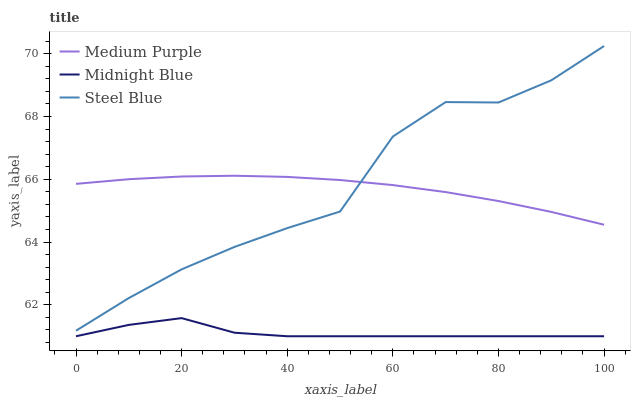Does Midnight Blue have the minimum area under the curve?
Answer yes or no. Yes. Does Steel Blue have the maximum area under the curve?
Answer yes or no. Yes. Does Steel Blue have the minimum area under the curve?
Answer yes or no. No. Does Midnight Blue have the maximum area under the curve?
Answer yes or no. No. Is Medium Purple the smoothest?
Answer yes or no. Yes. Is Steel Blue the roughest?
Answer yes or no. Yes. Is Midnight Blue the smoothest?
Answer yes or no. No. Is Midnight Blue the roughest?
Answer yes or no. No. Does Midnight Blue have the lowest value?
Answer yes or no. Yes. Does Steel Blue have the lowest value?
Answer yes or no. No. Does Steel Blue have the highest value?
Answer yes or no. Yes. Does Midnight Blue have the highest value?
Answer yes or no. No. Is Midnight Blue less than Steel Blue?
Answer yes or no. Yes. Is Medium Purple greater than Midnight Blue?
Answer yes or no. Yes. Does Steel Blue intersect Medium Purple?
Answer yes or no. Yes. Is Steel Blue less than Medium Purple?
Answer yes or no. No. Is Steel Blue greater than Medium Purple?
Answer yes or no. No. Does Midnight Blue intersect Steel Blue?
Answer yes or no. No. 